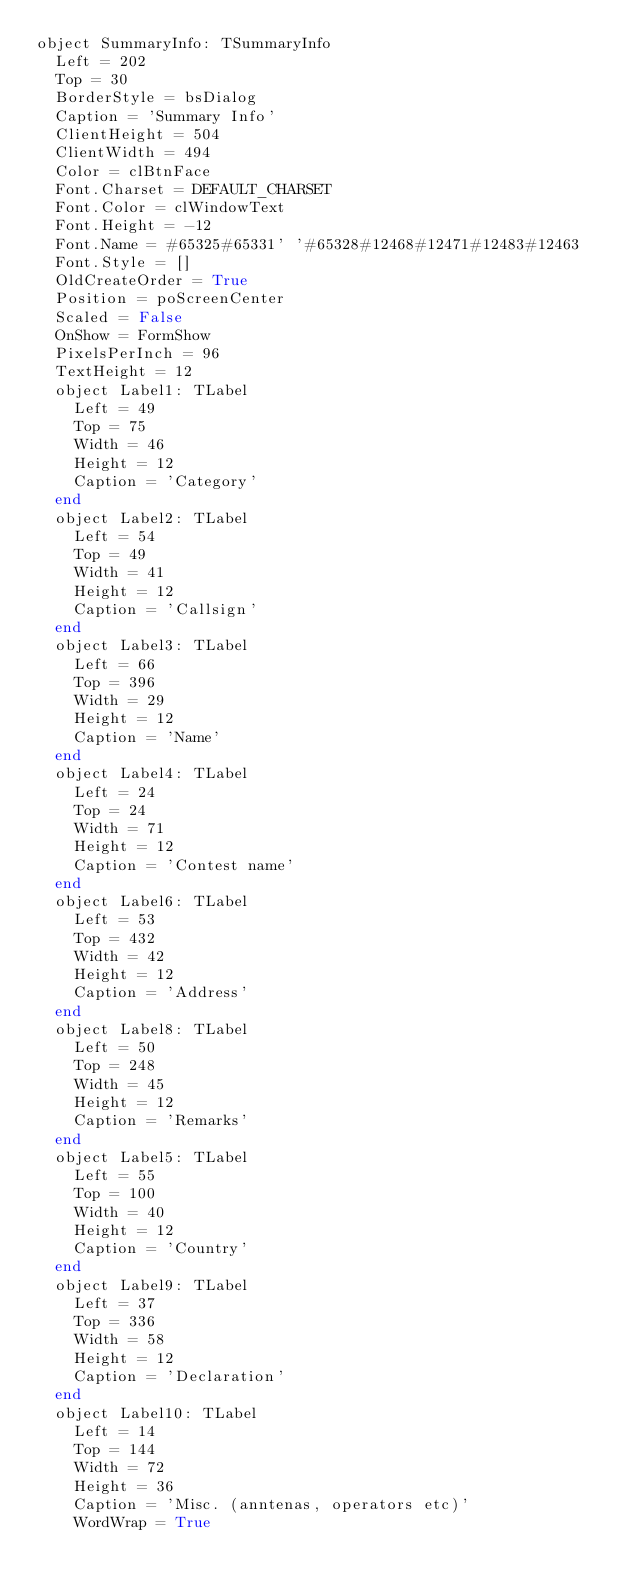<code> <loc_0><loc_0><loc_500><loc_500><_Pascal_>object SummaryInfo: TSummaryInfo
  Left = 202
  Top = 30
  BorderStyle = bsDialog
  Caption = 'Summary Info'
  ClientHeight = 504
  ClientWidth = 494
  Color = clBtnFace
  Font.Charset = DEFAULT_CHARSET
  Font.Color = clWindowText
  Font.Height = -12
  Font.Name = #65325#65331' '#65328#12468#12471#12483#12463
  Font.Style = []
  OldCreateOrder = True
  Position = poScreenCenter
  Scaled = False
  OnShow = FormShow
  PixelsPerInch = 96
  TextHeight = 12
  object Label1: TLabel
    Left = 49
    Top = 75
    Width = 46
    Height = 12
    Caption = 'Category'
  end
  object Label2: TLabel
    Left = 54
    Top = 49
    Width = 41
    Height = 12
    Caption = 'Callsign'
  end
  object Label3: TLabel
    Left = 66
    Top = 396
    Width = 29
    Height = 12
    Caption = 'Name'
  end
  object Label4: TLabel
    Left = 24
    Top = 24
    Width = 71
    Height = 12
    Caption = 'Contest name'
  end
  object Label6: TLabel
    Left = 53
    Top = 432
    Width = 42
    Height = 12
    Caption = 'Address'
  end
  object Label8: TLabel
    Left = 50
    Top = 248
    Width = 45
    Height = 12
    Caption = 'Remarks'
  end
  object Label5: TLabel
    Left = 55
    Top = 100
    Width = 40
    Height = 12
    Caption = 'Country'
  end
  object Label9: TLabel
    Left = 37
    Top = 336
    Width = 58
    Height = 12
    Caption = 'Declaration'
  end
  object Label10: TLabel
    Left = 14
    Top = 144
    Width = 72
    Height = 36
    Caption = 'Misc. (anntenas, operators etc)'
    WordWrap = True</code> 